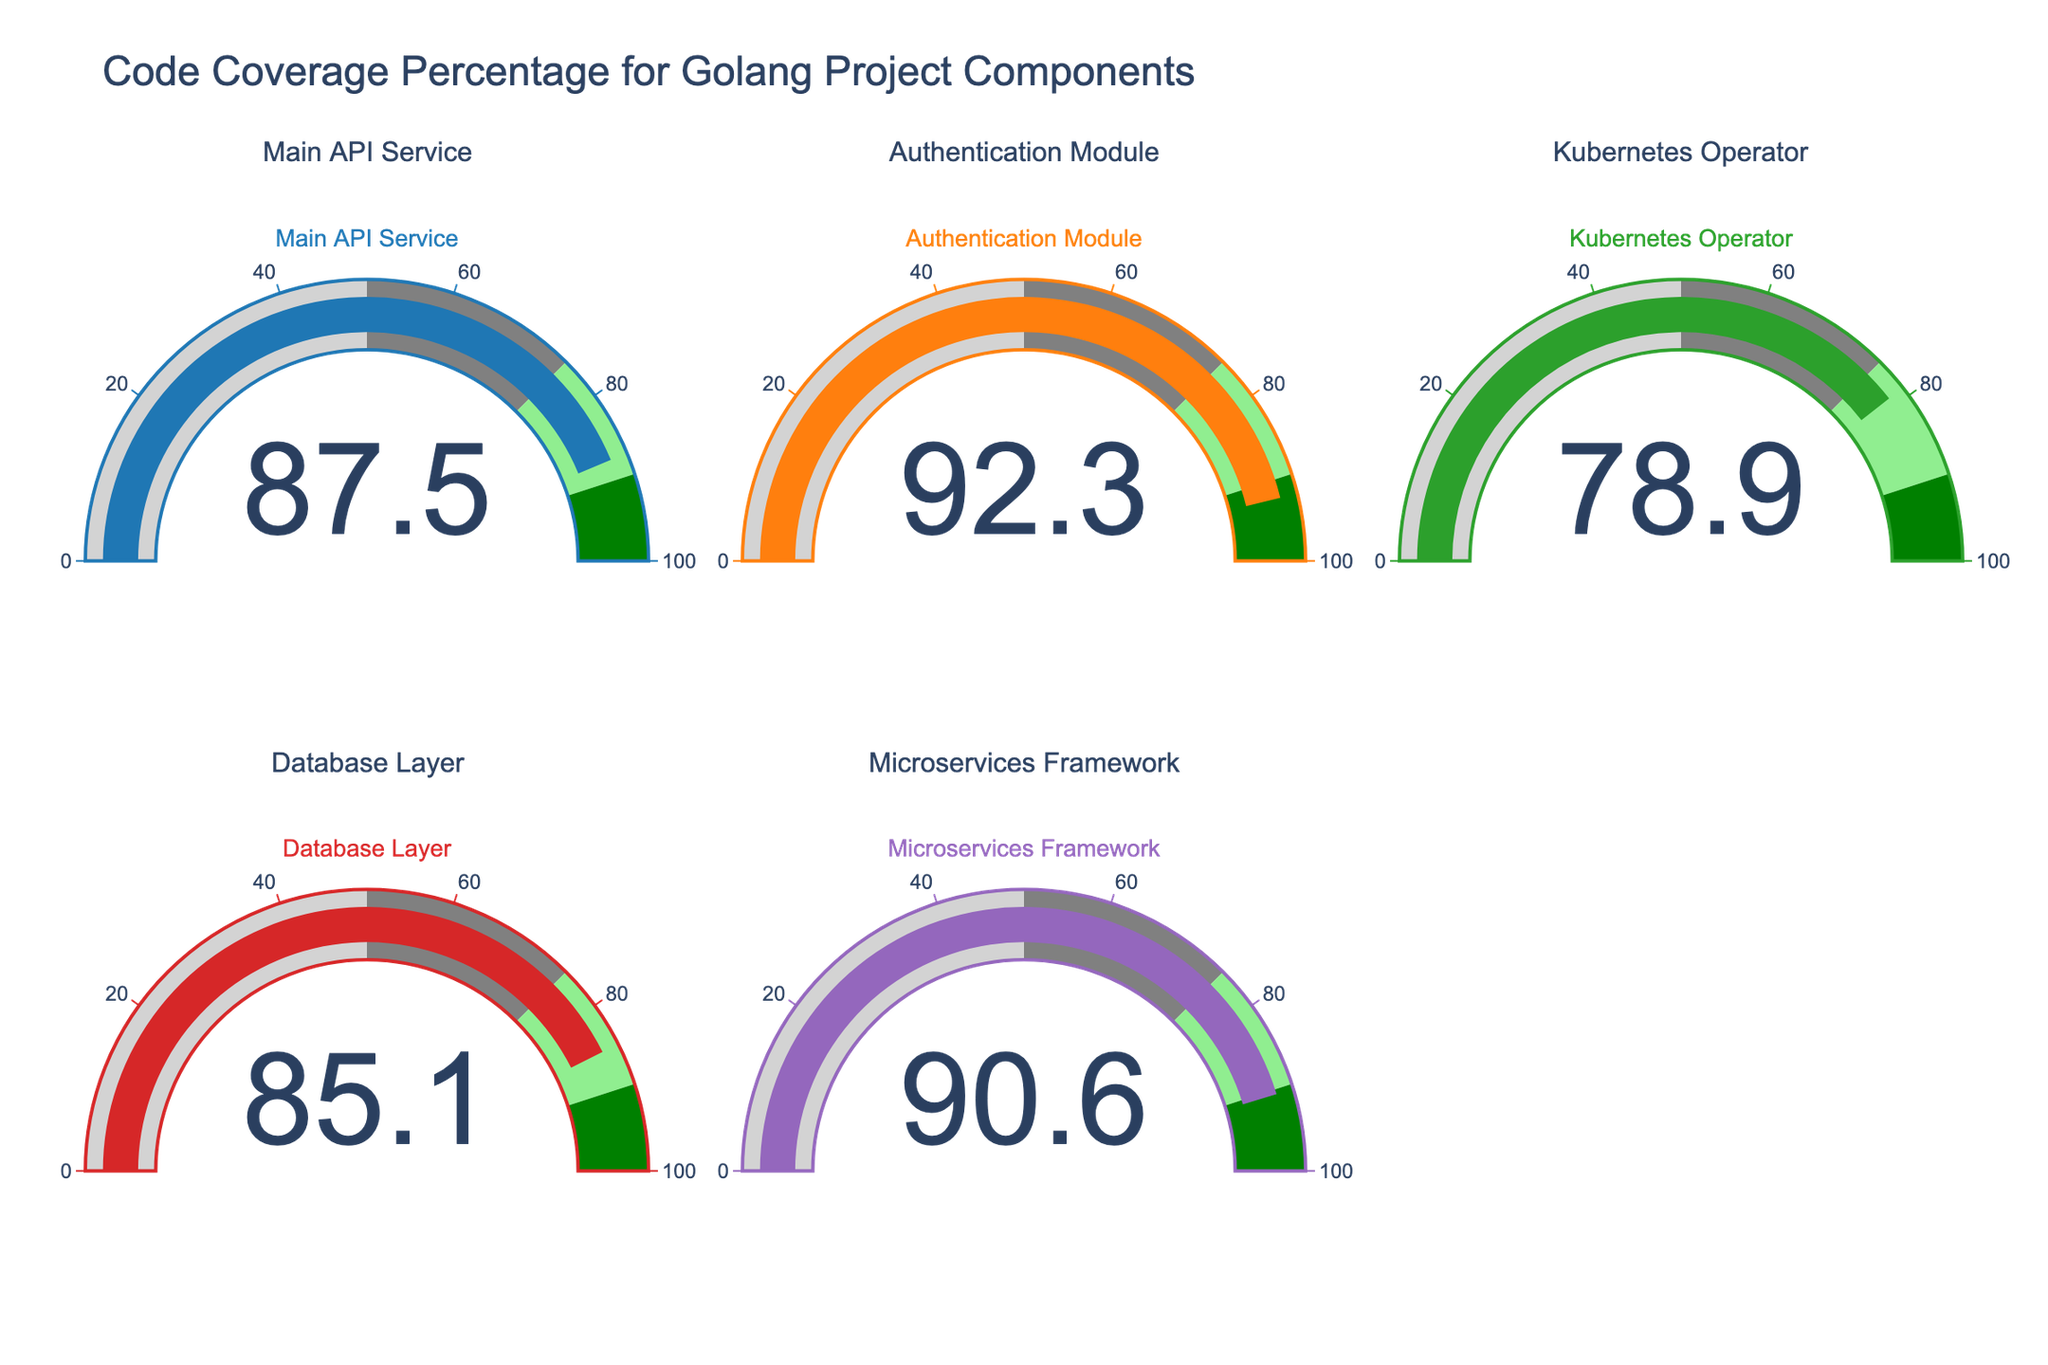What is the code test coverage percentage for the Main API Service? The figure shows an individual gauge displaying the code test coverage percentage for the Main API Service, which is labeled as 87.5%.
Answer: 87.5% Which component has the lowest code test coverage? By comparing the percentages on all gauges, the Kubernetes Operator has the lowest code test coverage at 78.9%.
Answer: Kubernetes Operator How many components have a code test coverage percentage above 90%? From the figures, both the Authentication Module (92.3%) and the Microservices Framework (90.6%) exceed the 90% coverage threshold. Hence, 2 components meet this criterion.
Answer: 2 What is the average code test coverage across all listed components? First, sum all the coverage percentages: 87.5 + 92.3 + 78.9 + 85.1 + 90.6 = 434.4. Then divide by the number of components, which is 5. So, 434.4 / 5 = 86.88.
Answer: 86.88 Which component has the highest code test coverage, and what is it? By observing the gauges, the Authentication Module has the highest coverage at 92.3%.
Answer: Authentication Module (92.3%) Is the code test coverage of the Database Layer above the average coverage of all components? First, calculate the average coverage as 86.88%, then compare it to the Database Layer's coverage of 85.1%, which is below average.
Answer: No What is the total code test coverage of the Main API Service and the Kubernetes Operator combined? Sum the coverage percentages of the Main API Service (87.5%) and the Kubernetes Operator (78.9%): 87.5 + 78.9 = 166.4.
Answer: 166.4 How does the code test coverage for the Microservices Framework compare to that of the Database Layer? The Microservices Framework has a coverage of 90.6%, while the Database Layer has 85.1%. The former is higher.
Answer: Higher 